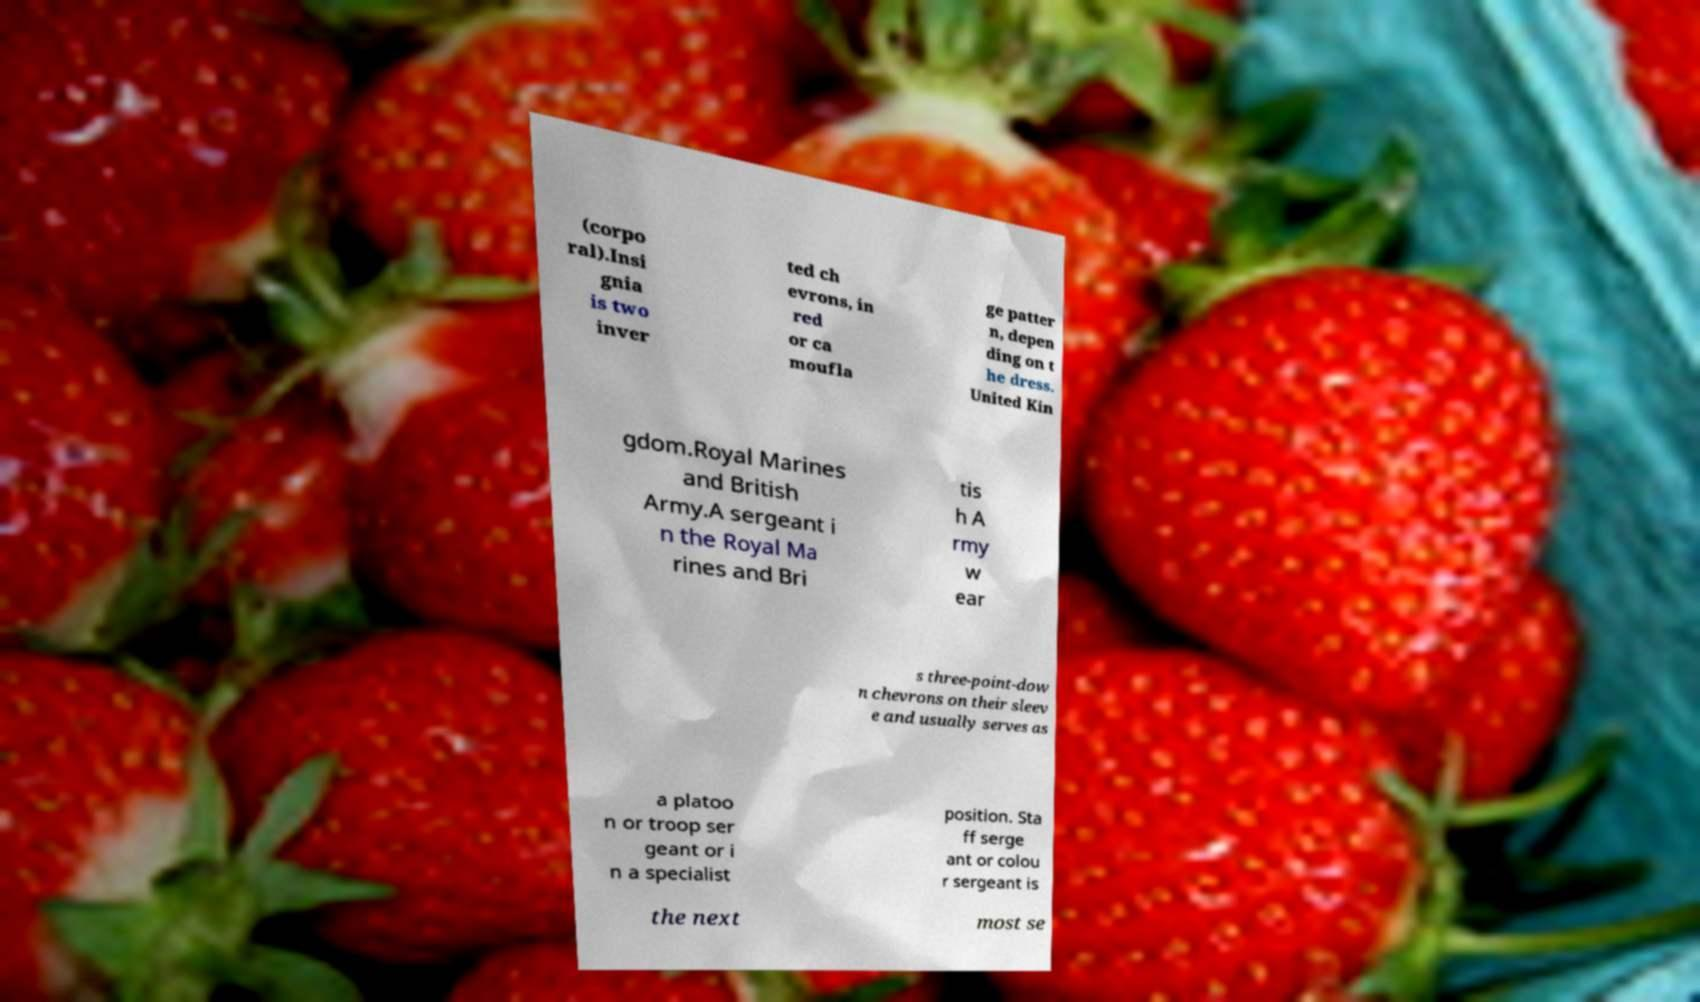Can you read and provide the text displayed in the image?This photo seems to have some interesting text. Can you extract and type it out for me? (corpo ral).Insi gnia is two inver ted ch evrons, in red or ca moufla ge patter n, depen ding on t he dress. United Kin gdom.Royal Marines and British Army.A sergeant i n the Royal Ma rines and Bri tis h A rmy w ear s three-point-dow n chevrons on their sleev e and usually serves as a platoo n or troop ser geant or i n a specialist position. Sta ff serge ant or colou r sergeant is the next most se 